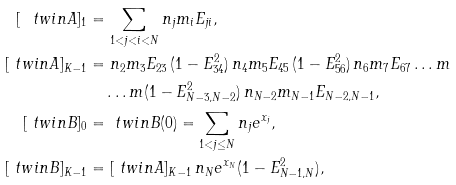Convert formula to latex. <formula><loc_0><loc_0><loc_500><loc_500>[ \ t w i n A ] _ { 1 } & = \sum _ { 1 < j < i < N } n _ { j } m _ { i } E _ { j i } , \\ [ \ t w i n A ] _ { K - 1 } & = n _ { 2 } m _ { 3 } E _ { 2 3 } \, ( 1 - E _ { 3 4 } ^ { 2 } ) \, n _ { 4 } m _ { 5 } E _ { 4 5 } \, ( 1 - E _ { 5 6 } ^ { 2 } ) \, n _ { 6 } m _ { 7 } E _ { 6 7 } \dots m \\ & \quad \dots m ( 1 - E _ { N - 3 , N - 2 } ^ { 2 } ) \, n _ { N - 2 } m _ { N - 1 } E _ { N - 2 , N - 1 } , \\ [ \ t w i n B ] _ { 0 } & = \ t w i n B ( 0 ) = \sum _ { 1 < j \leq N } n _ { j } e ^ { x _ { j } } , \\ [ \ t w i n B ] _ { K - 1 } & = [ \ t w i n A ] _ { K - 1 } \, n _ { N } e ^ { x _ { N } } ( 1 - E _ { N - 1 , N } ^ { 2 } ) ,</formula> 